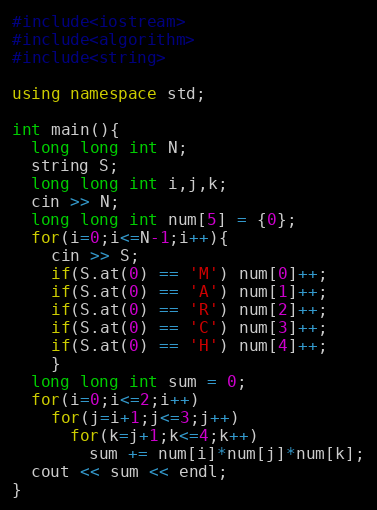<code> <loc_0><loc_0><loc_500><loc_500><_C++_>#include<iostream>
#include<algorithm>
#include<string>

using namespace std;

int main(){
  long long int N;
  string S;
  long long int i,j,k;
  cin >> N;
  long long int num[5] = {0};
  for(i=0;i<=N-1;i++){
    cin >> S;
    if(S.at(0) == 'M') num[0]++;
    if(S.at(0) == 'A') num[1]++;
    if(S.at(0) == 'R') num[2]++;
    if(S.at(0) == 'C') num[3]++;
    if(S.at(0) == 'H') num[4]++;
    }  
  long long int sum = 0;
  for(i=0;i<=2;i++)
    for(j=i+1;j<=3;j++)
      for(k=j+1;k<=4;k++)
        sum += num[i]*num[j]*num[k];
  cout << sum << endl;
}</code> 